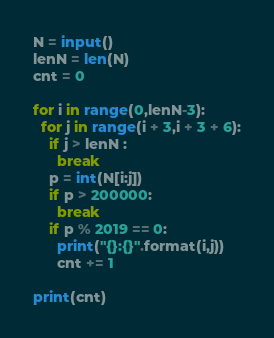Convert code to text. <code><loc_0><loc_0><loc_500><loc_500><_Python_>N = input()
lenN = len(N)
cnt = 0
  
for i in range(0,lenN-3):
  for j in range(i + 3,i + 3 + 6):
    if j > lenN :
      break
    p = int(N[i:j])
    if p > 200000:
      break
    if p % 2019 == 0:
      print("{}:{}".format(i,j))
      cnt += 1

print(cnt)</code> 